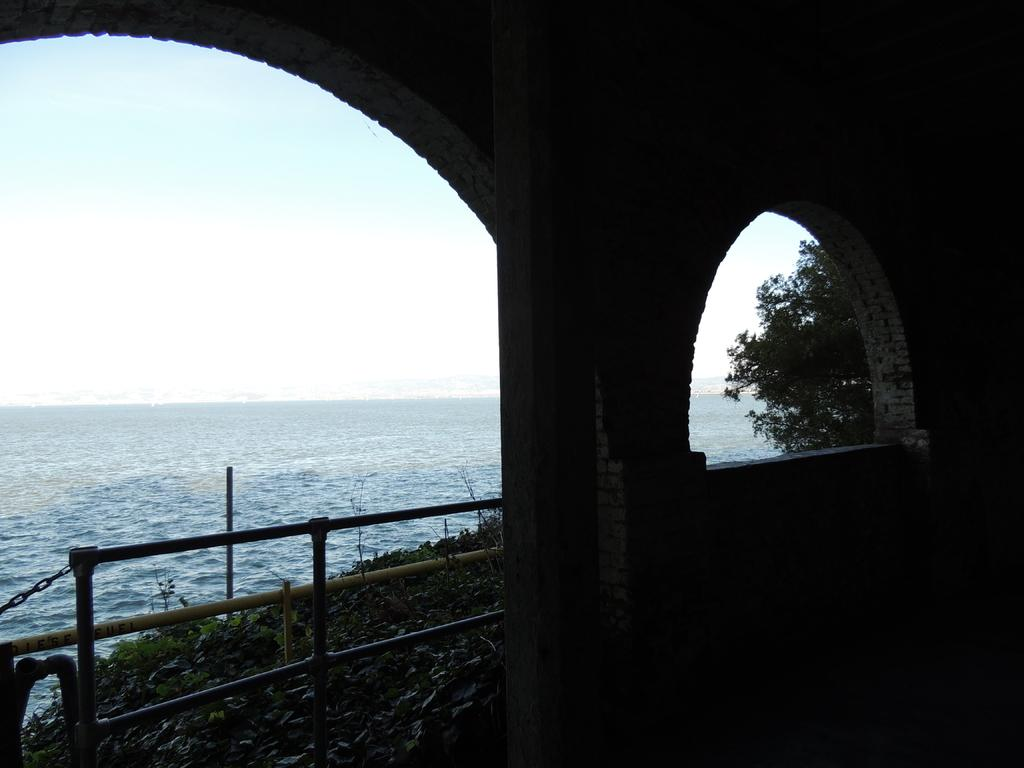What is one of the natural elements visible in the image? Water is visible in the image. What type of vegetation can be seen in the image? Plants and trees are visible in the image. What type of structure is present in the image? There is a building in the image. What part of the natural environment is visible in the image? The sky is visible in the image. Can you see a bean growing in the image? There is no bean growing in the image. What type of smile can be seen on the trees in the image? There are no smiles on the trees in the image, as trees do not have facial expressions. 